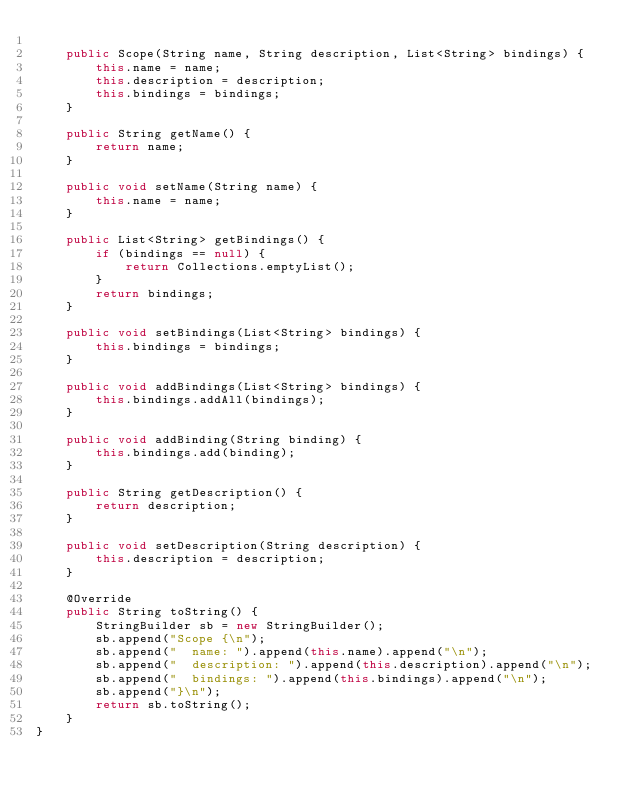<code> <loc_0><loc_0><loc_500><loc_500><_Java_>
    public Scope(String name, String description, List<String> bindings) {
        this.name = name;
        this.description = description;
        this.bindings = bindings;
    }

    public String getName() {
        return name;
    }

    public void setName(String name) {
        this.name = name;
    }

    public List<String> getBindings() {
        if (bindings == null) {
            return Collections.emptyList();
        }
        return bindings;
    }

    public void setBindings(List<String> bindings) {
        this.bindings = bindings;
    }

    public void addBindings(List<String> bindings) {
        this.bindings.addAll(bindings);
    }

    public void addBinding(String binding) {
        this.bindings.add(binding);
    }

    public String getDescription() {
        return description;
    }

    public void setDescription(String description) {
        this.description = description;
    }

    @Override
    public String toString() {
        StringBuilder sb = new StringBuilder();
        sb.append("Scope {\n");
        sb.append("  name: ").append(this.name).append("\n");
        sb.append("  description: ").append(this.description).append("\n");
        sb.append("  bindings: ").append(this.bindings).append("\n");
        sb.append("}\n");
        return sb.toString();
    }
}

</code> 